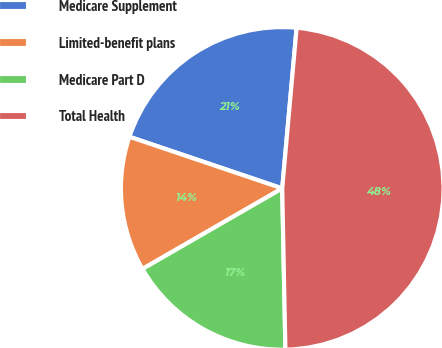Convert chart. <chart><loc_0><loc_0><loc_500><loc_500><pie_chart><fcel>Medicare Supplement<fcel>Limited-benefit plans<fcel>Medicare Part D<fcel>Total Health<nl><fcel>21.24%<fcel>13.51%<fcel>16.99%<fcel>48.26%<nl></chart> 